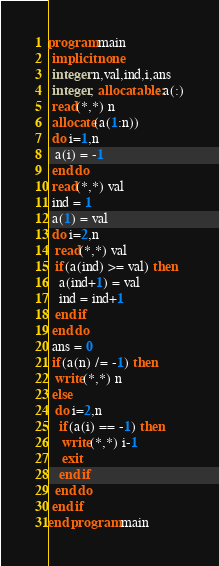Convert code to text. <code><loc_0><loc_0><loc_500><loc_500><_FORTRAN_>program main
 implicit none
 integer n,val,ind,i,ans
 integer, allocatable::a(:)
 read(*,*) n
 allocate(a(1:n))
 do i=1,n
  a(i) = -1
 end do
 read(*,*) val
 ind = 1
 a(1) = val
 do i=2,n
  read(*,*) val
  if(a(ind) >= val) then
   a(ind+1) = val
   ind = ind+1
  end if
 end do
 ans = 0
 if(a(n) /= -1) then
  write(*,*) n
 else
  do i=2,n
   if(a(i) == -1) then
    write(*,*) i-1
    exit
   end if
  end do
 end if
end program main</code> 